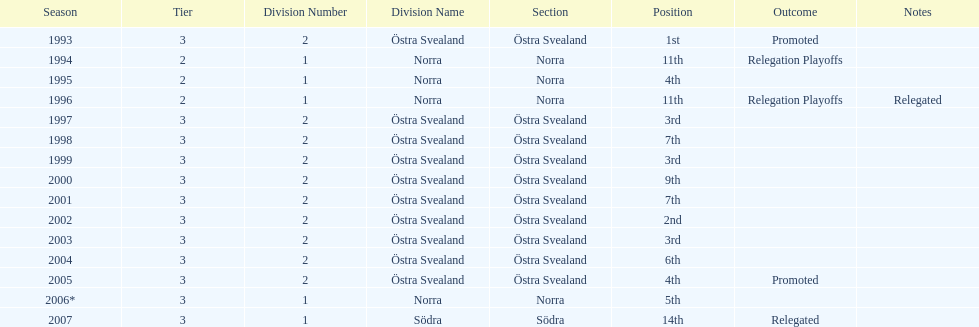In total, how many times were they promoted? 2. 